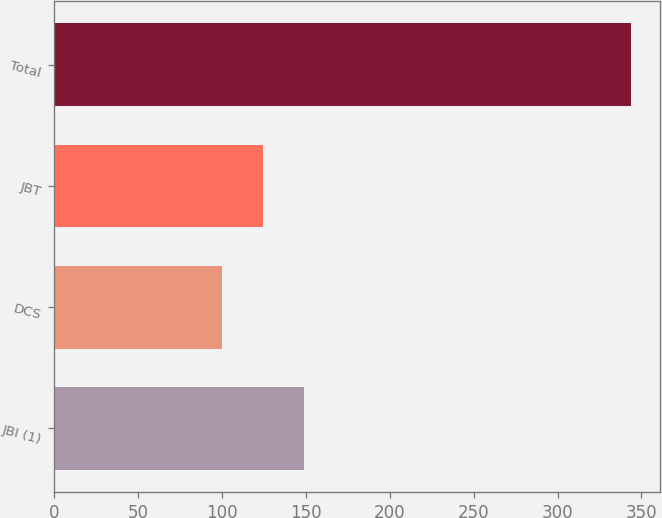Convert chart. <chart><loc_0><loc_0><loc_500><loc_500><bar_chart><fcel>JBI (1)<fcel>DCS<fcel>JBT<fcel>Total<nl><fcel>148.8<fcel>100<fcel>124.4<fcel>344<nl></chart> 